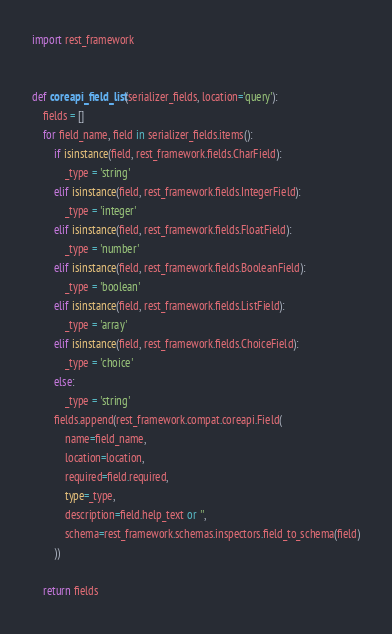<code> <loc_0><loc_0><loc_500><loc_500><_Python_>import rest_framework


def coreapi_field_list(serializer_fields, location='query'):
    fields = []
    for field_name, field in serializer_fields.items():
        if isinstance(field, rest_framework.fields.CharField):
            _type = 'string'
        elif isinstance(field, rest_framework.fields.IntegerField):
            _type = 'integer'
        elif isinstance(field, rest_framework.fields.FloatField):
            _type = 'number'
        elif isinstance(field, rest_framework.fields.BooleanField):
            _type = 'boolean'
        elif isinstance(field, rest_framework.fields.ListField):
            _type = 'array'
        elif isinstance(field, rest_framework.fields.ChoiceField):
            _type = 'choice'
        else:
            _type = 'string'
        fields.append(rest_framework.compat.coreapi.Field(
            name=field_name,
            location=location,
            required=field.required,
            type=_type,
            description=field.help_text or '',
            schema=rest_framework.schemas.inspectors.field_to_schema(field)
        ))

    return fields
</code> 